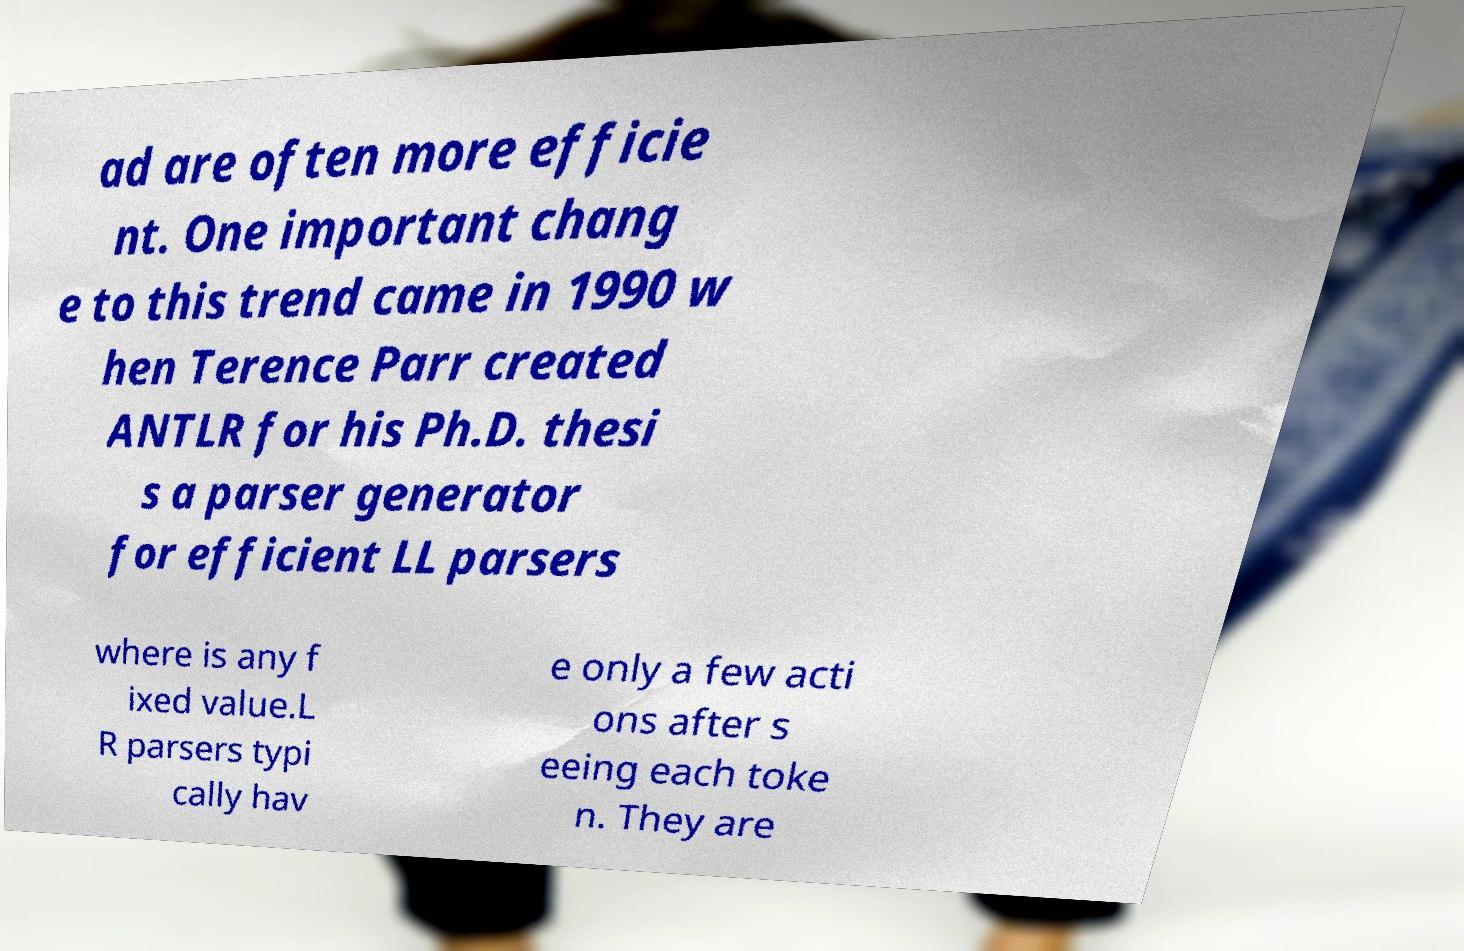Please identify and transcribe the text found in this image. ad are often more efficie nt. One important chang e to this trend came in 1990 w hen Terence Parr created ANTLR for his Ph.D. thesi s a parser generator for efficient LL parsers where is any f ixed value.L R parsers typi cally hav e only a few acti ons after s eeing each toke n. They are 